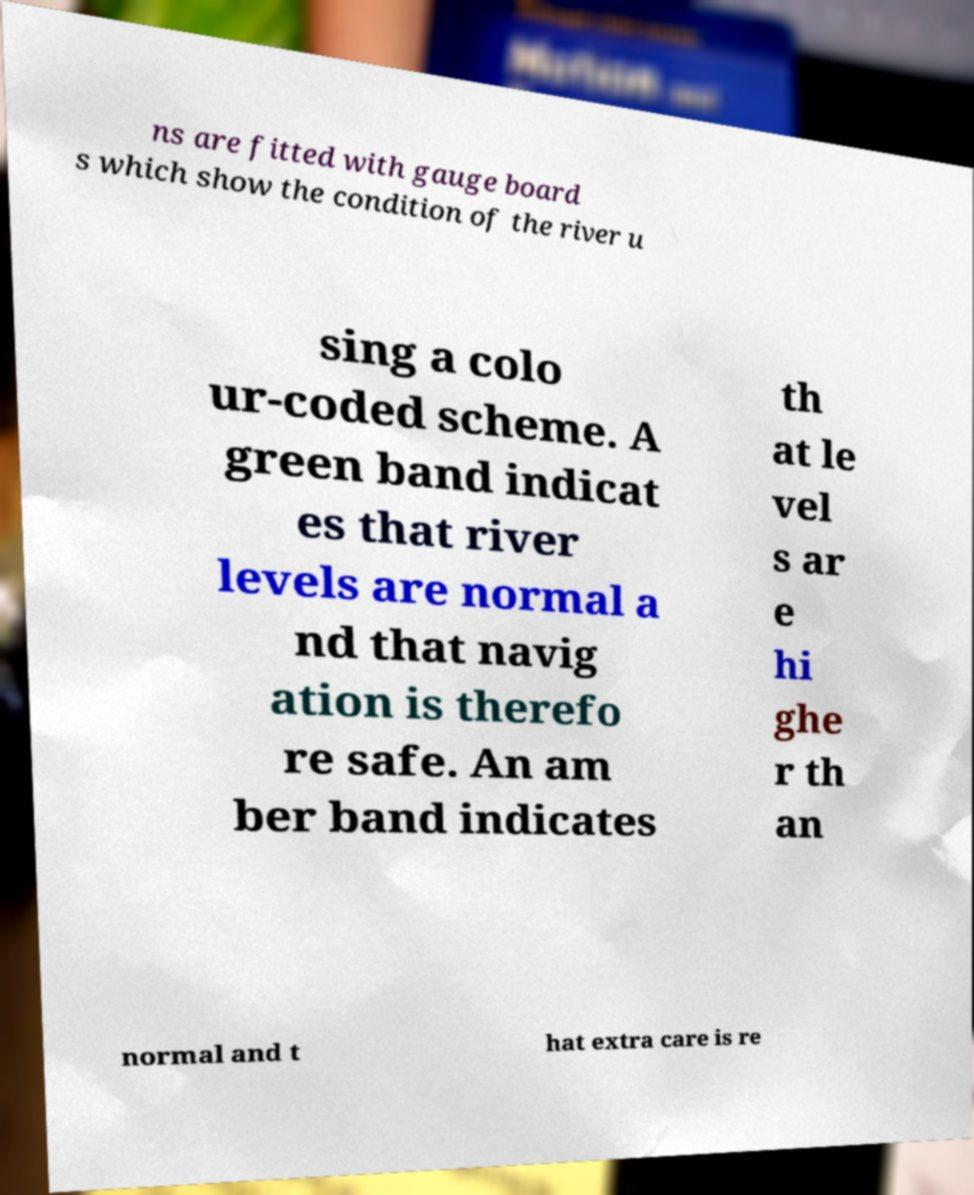Can you accurately transcribe the text from the provided image for me? ns are fitted with gauge board s which show the condition of the river u sing a colo ur-coded scheme. A green band indicat es that river levels are normal a nd that navig ation is therefo re safe. An am ber band indicates th at le vel s ar e hi ghe r th an normal and t hat extra care is re 